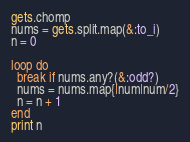<code> <loc_0><loc_0><loc_500><loc_500><_Ruby_>gets.chomp
nums = gets.split.map(&:to_i)
n = 0

loop do 
  break if nums.any?(&:odd?)
  nums = nums.map{|num|num/2}
  n = n + 1
end
print n</code> 